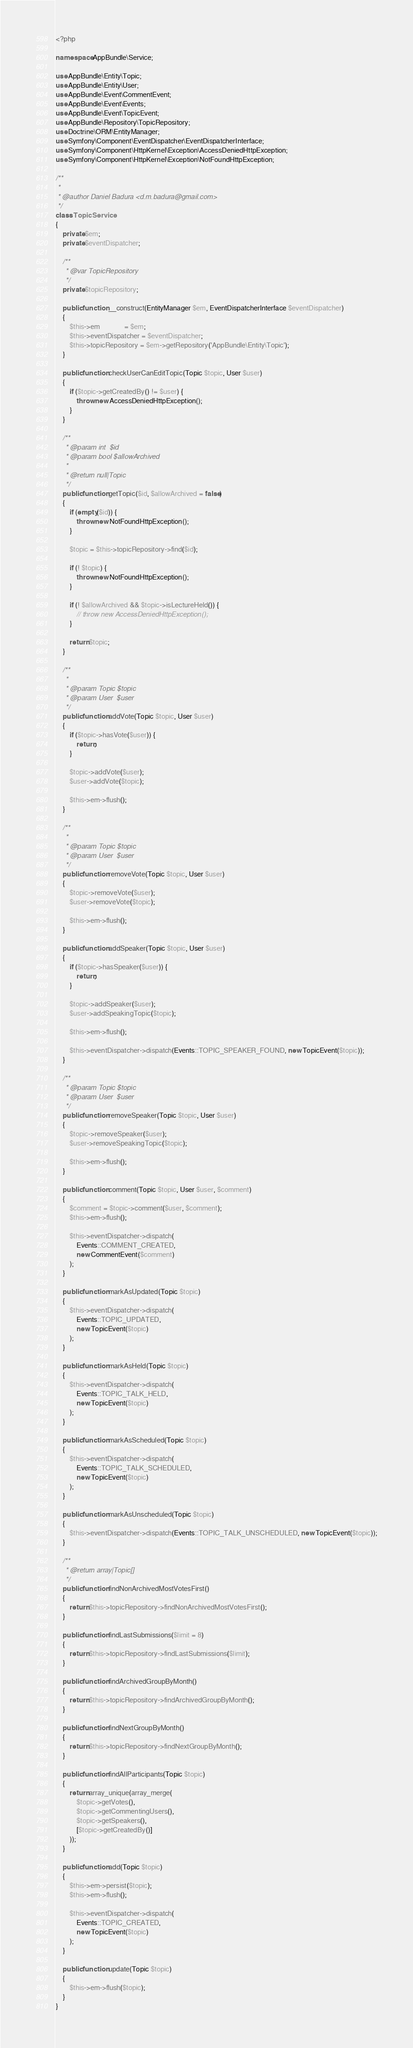Convert code to text. <code><loc_0><loc_0><loc_500><loc_500><_PHP_><?php

namespace AppBundle\Service;

use AppBundle\Entity\Topic;
use AppBundle\Entity\User;
use AppBundle\Event\CommentEvent;
use AppBundle\Event\Events;
use AppBundle\Event\TopicEvent;
use AppBundle\Repository\TopicRepository;
use Doctrine\ORM\EntityManager;
use Symfony\Component\EventDispatcher\EventDispatcherInterface;
use Symfony\Component\HttpKernel\Exception\AccessDeniedHttpException;
use Symfony\Component\HttpKernel\Exception\NotFoundHttpException;

/**
 *
 * @author Daniel Badura <d.m.badura@gmail.com>
 */
class TopicService
{
    private $em;
    private $eventDispatcher;

    /**
     * @var TopicRepository
     */
    private $topicRepository;

    public function __construct(EntityManager $em, EventDispatcherInterface $eventDispatcher)
    {
        $this->em              = $em;
        $this->eventDispatcher = $eventDispatcher;
        $this->topicRepository = $em->getRepository('AppBundle\Entity\Topic');
    }

    public function checkUserCanEditTopic(Topic $topic, User $user)
    {
        if ($topic->getCreatedBy() != $user) {
            throw new AccessDeniedHttpException();
        }
    }

    /**
     * @param int  $id
     * @param bool $allowArchived
     *
     * @return null|Topic
     */
    public function getTopic($id, $allowArchived = false)
    {
        if (empty($id)) {
            throw new NotFoundHttpException();
        }

        $topic = $this->topicRepository->find($id);

        if (! $topic) {
            throw new NotFoundHttpException();
        }

        if (! $allowArchived && $topic->isLectureHeld()) {
            // throw new AccessDeniedHttpException();
        }

        return $topic;
    }

    /**
     *
     * @param Topic $topic
     * @param User  $user
     */
    public function addVote(Topic $topic, User $user)
    {
        if ($topic->hasVote($user)) {
            return;
        }

        $topic->addVote($user);
        $user->addVote($topic);

        $this->em->flush();
    }

    /**
     *
     * @param Topic $topic
     * @param User  $user
     */
    public function removeVote(Topic $topic, User $user)
    {
        $topic->removeVote($user);
        $user->removeVote($topic);

        $this->em->flush();
    }

    public function addSpeaker(Topic $topic, User $user)
    {
        if ($topic->hasSpeaker($user)) {
            return;
        }

        $topic->addSpeaker($user);
        $user->addSpeakingTopic($topic);

        $this->em->flush();

        $this->eventDispatcher->dispatch(Events::TOPIC_SPEAKER_FOUND, new TopicEvent($topic));
    }

    /**
     * @param Topic $topic
     * @param User  $user
     */
    public function removeSpeaker(Topic $topic, User $user)
    {
        $topic->removeSpeaker($user);
        $user->removeSpeakingTopic($topic);

        $this->em->flush();
    }

    public function comment(Topic $topic, User $user, $comment)
    {
        $comment = $topic->comment($user, $comment);
        $this->em->flush();

        $this->eventDispatcher->dispatch(
            Events::COMMENT_CREATED,
            new CommentEvent($comment)
        );
    }

    public function markAsUpdated(Topic $topic)
    {
        $this->eventDispatcher->dispatch(
            Events::TOPIC_UPDATED,
            new TopicEvent($topic)
        );
    }

    public function markAsHeld(Topic $topic)
    {
        $this->eventDispatcher->dispatch(
            Events::TOPIC_TALK_HELD,
            new TopicEvent($topic)
        );
    }

    public function markAsScheduled(Topic $topic)
    {
        $this->eventDispatcher->dispatch(
            Events::TOPIC_TALK_SCHEDULED,
            new TopicEvent($topic)
        );
    }

    public function markAsUnscheduled(Topic $topic)
    {
        $this->eventDispatcher->dispatch(Events::TOPIC_TALK_UNSCHEDULED, new TopicEvent($topic));
    }

    /**
     * @return array|Topic[]
     */
    public function findNonArchivedMostVotesFirst()
    {
        return $this->topicRepository->findNonArchivedMostVotesFirst();
    }

    public function findLastSubmissions($limit = 8)
    {
        return $this->topicRepository->findLastSubmissions($limit);
    }

    public function findArchivedGroupByMonth()
    {
        return $this->topicRepository->findArchivedGroupByMonth();
    }

    public function findNextGroupByMonth()
    {
        return $this->topicRepository->findNextGroupByMonth();
    }

    public function findAllParticipants(Topic $topic)
    {
        return array_unique(array_merge(
            $topic->getVotes(),
            $topic->getCommentingUsers(),
            $topic->getSpeakers(),
            [$topic->getCreatedBy()]
        ));
    }

    public function add(Topic $topic)
    {
        $this->em->persist($topic);
        $this->em->flush();

        $this->eventDispatcher->dispatch(
            Events::TOPIC_CREATED,
            new TopicEvent($topic)
        );
    }

    public function update(Topic $topic)
    {
        $this->em->flush($topic);
    }
}
</code> 